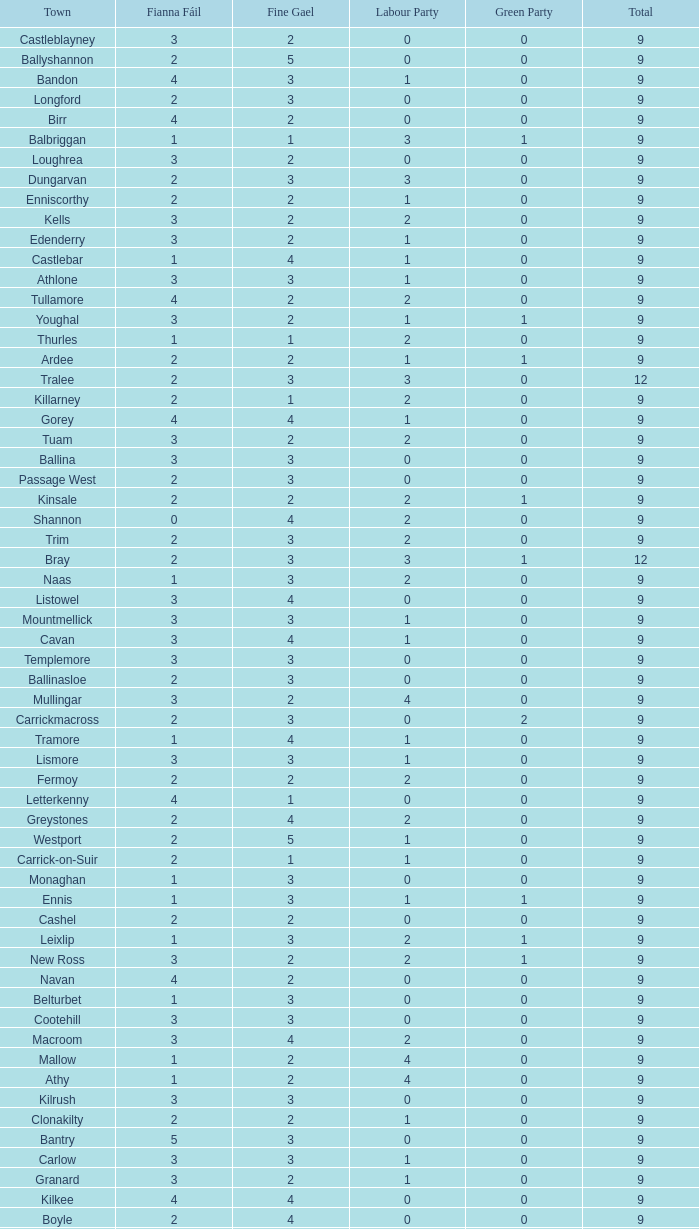How many are in the Labour Party of a Fianna Fail of 3 with a total higher than 9 and more than 2 in the Green Party? None. 